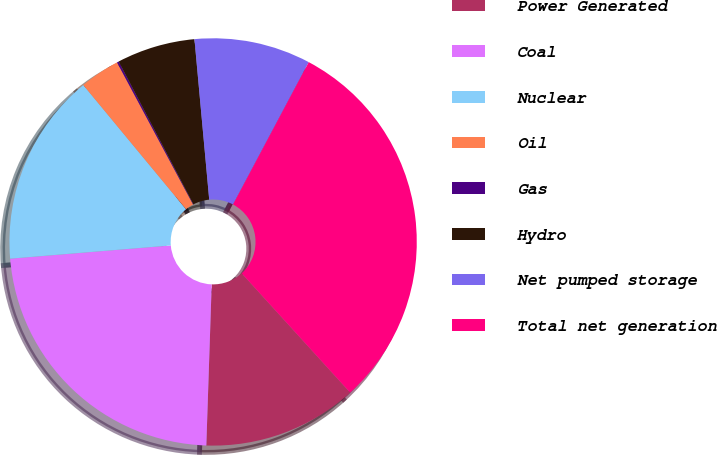Convert chart to OTSL. <chart><loc_0><loc_0><loc_500><loc_500><pie_chart><fcel>Power Generated<fcel>Coal<fcel>Nuclear<fcel>Oil<fcel>Gas<fcel>Hydro<fcel>Net pumped storage<fcel>Total net generation<nl><fcel>12.28%<fcel>23.16%<fcel>15.31%<fcel>3.18%<fcel>0.15%<fcel>6.21%<fcel>9.24%<fcel>30.47%<nl></chart> 